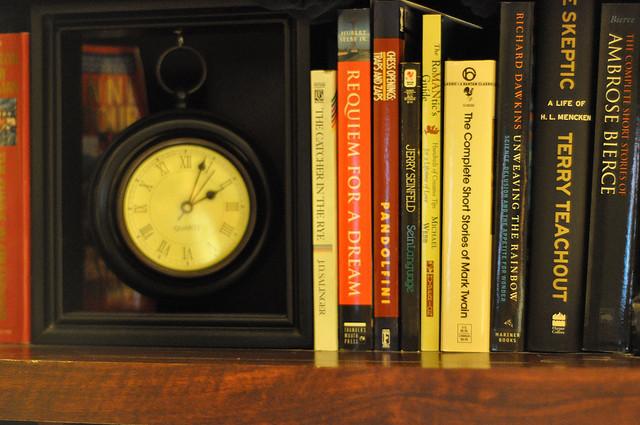How many books are there to the right of the clock?
Quick response, please. 9. What time is it?
Keep it brief. 2:03. Are the books on the right?
Quick response, please. Yes. 